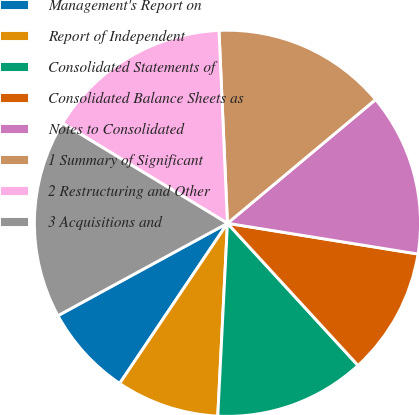<chart> <loc_0><loc_0><loc_500><loc_500><pie_chart><fcel>Management's Report on<fcel>Report of Independent<fcel>Consolidated Statements of<fcel>Consolidated Balance Sheets as<fcel>Notes to Consolidated<fcel>1 Summary of Significant<fcel>2 Restructuring and Other<fcel>3 Acquisitions and<nl><fcel>7.63%<fcel>8.63%<fcel>12.62%<fcel>10.63%<fcel>13.62%<fcel>14.62%<fcel>15.62%<fcel>16.62%<nl></chart> 